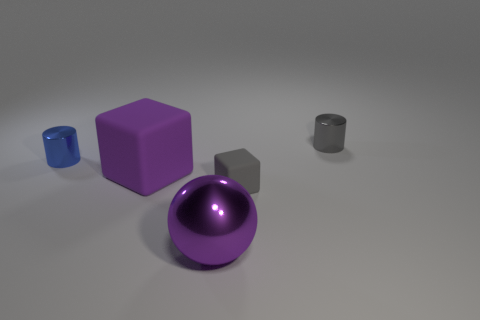Add 4 large shiny spheres. How many objects exist? 9 Subtract all cylinders. How many objects are left? 3 Subtract 0 brown balls. How many objects are left? 5 Subtract all small blue matte cubes. Subtract all purple rubber objects. How many objects are left? 4 Add 4 tiny blue metallic objects. How many tiny blue metallic objects are left? 5 Add 5 small gray shiny cylinders. How many small gray shiny cylinders exist? 6 